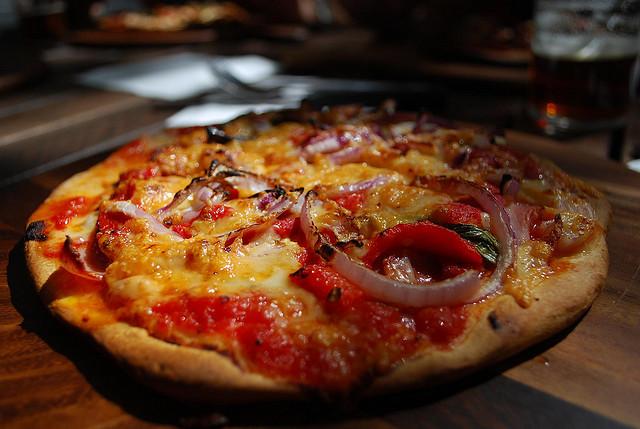What toppings are on the pizza?
Quick response, please. Onions. Where is the pizza placed?
Be succinct. Table. What does the counter look to be made of?
Keep it brief. Wood. What kind of food is this?
Be succinct. Pizza. 